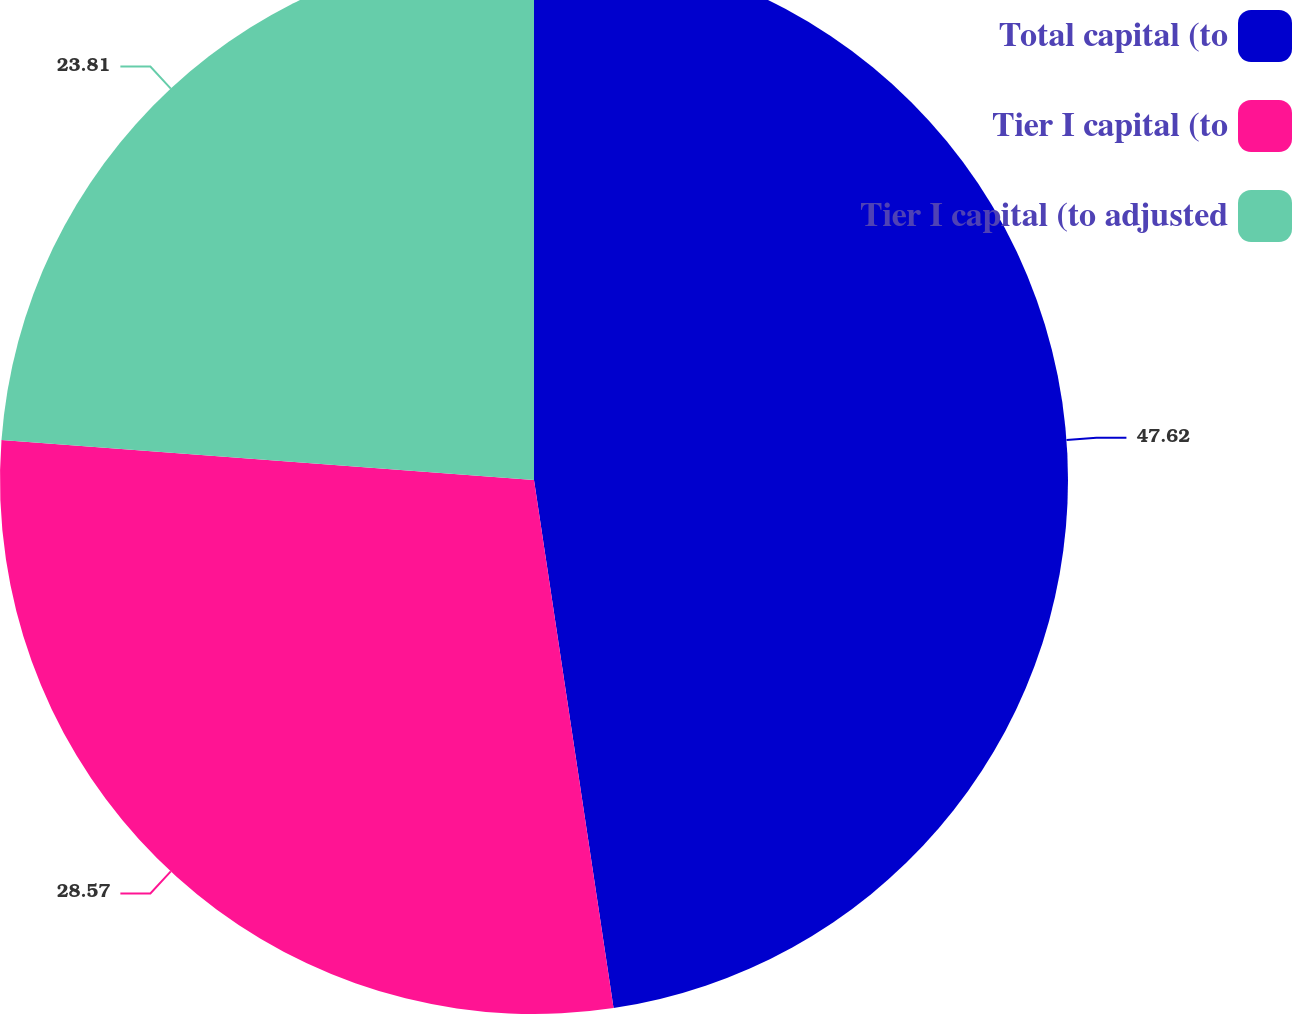<chart> <loc_0><loc_0><loc_500><loc_500><pie_chart><fcel>Total capital (to<fcel>Tier I capital (to<fcel>Tier I capital (to adjusted<nl><fcel>47.62%<fcel>28.57%<fcel>23.81%<nl></chart> 